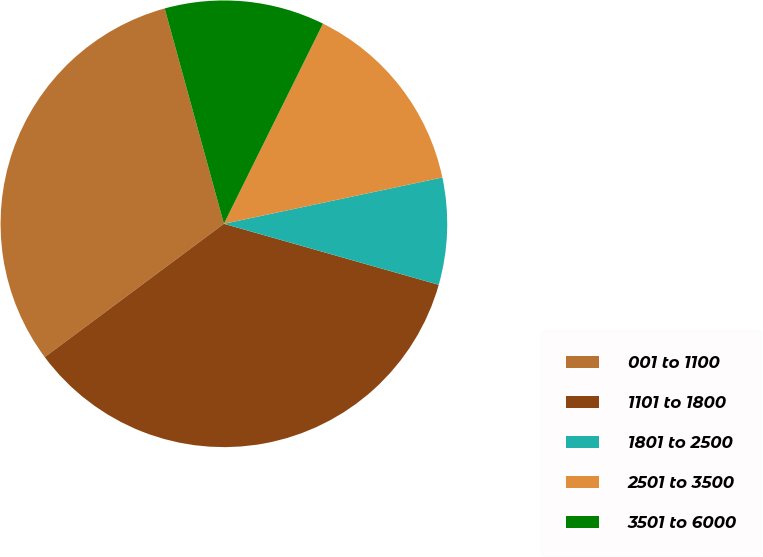<chart> <loc_0><loc_0><loc_500><loc_500><pie_chart><fcel>001 to 1100<fcel>1101 to 1800<fcel>1801 to 2500<fcel>2501 to 3500<fcel>3501 to 6000<nl><fcel>30.91%<fcel>35.42%<fcel>7.73%<fcel>14.36%<fcel>11.59%<nl></chart> 